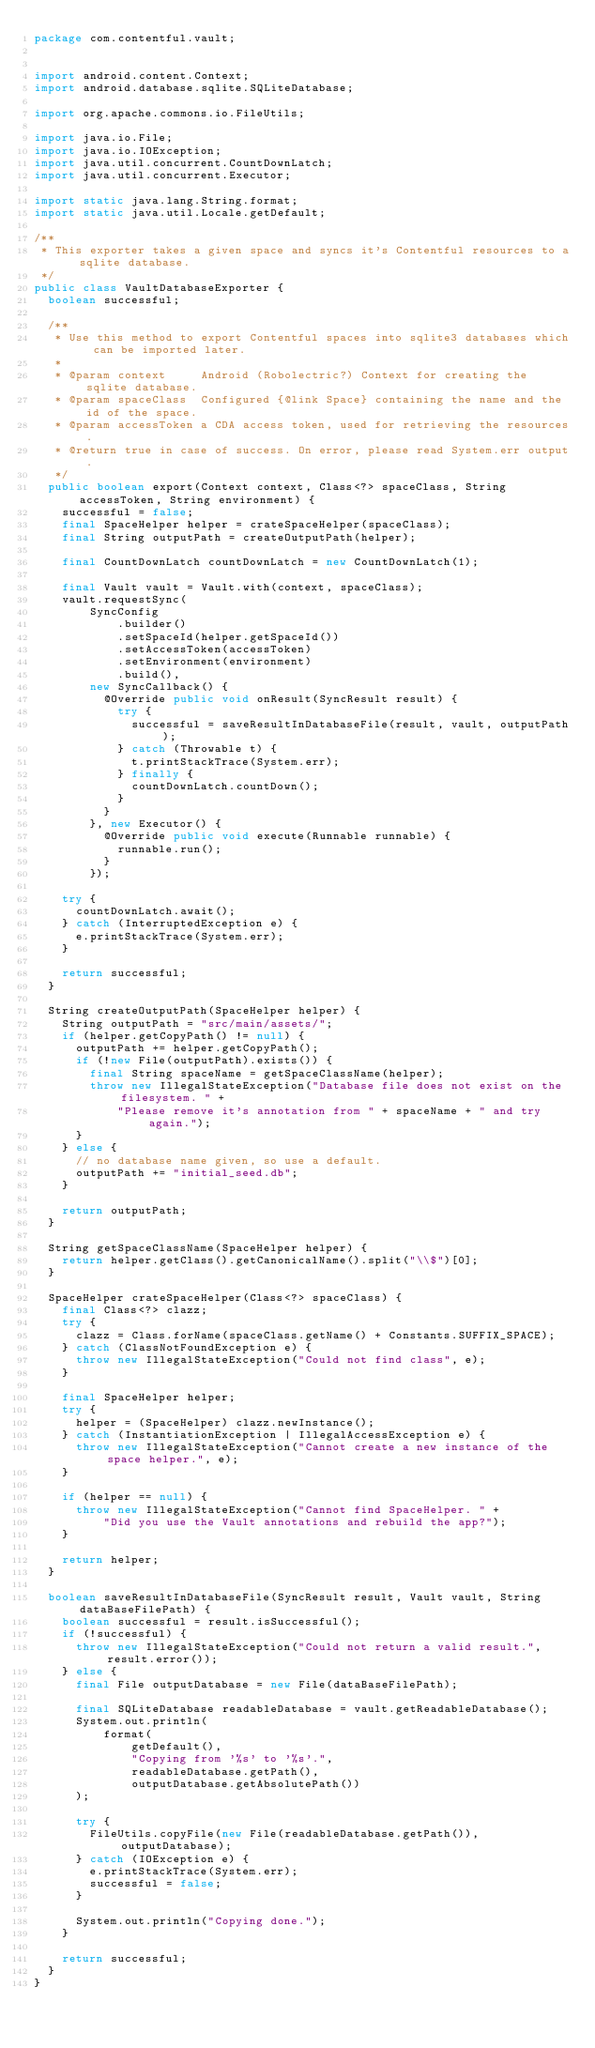Convert code to text. <code><loc_0><loc_0><loc_500><loc_500><_Java_>package com.contentful.vault;


import android.content.Context;
import android.database.sqlite.SQLiteDatabase;

import org.apache.commons.io.FileUtils;

import java.io.File;
import java.io.IOException;
import java.util.concurrent.CountDownLatch;
import java.util.concurrent.Executor;

import static java.lang.String.format;
import static java.util.Locale.getDefault;

/**
 * This exporter takes a given space and syncs it's Contentful resources to a sqlite database.
 */
public class VaultDatabaseExporter {
  boolean successful;

  /**
   * Use this method to export Contentful spaces into sqlite3 databases which can be imported later.
   *
   * @param context     Android (Robolectric?) Context for creating the sqlite database.
   * @param spaceClass  Configured {@link Space} containing the name and the id of the space.
   * @param accessToken a CDA access token, used for retrieving the resources.
   * @return true in case of success. On error, please read System.err output.
   */
  public boolean export(Context context, Class<?> spaceClass, String accessToken, String environment) {
    successful = false;
    final SpaceHelper helper = crateSpaceHelper(spaceClass);
    final String outputPath = createOutputPath(helper);

    final CountDownLatch countDownLatch = new CountDownLatch(1);

    final Vault vault = Vault.with(context, spaceClass);
    vault.requestSync(
        SyncConfig
            .builder()
            .setSpaceId(helper.getSpaceId())
            .setAccessToken(accessToken)
            .setEnvironment(environment)
            .build(),
        new SyncCallback() {
          @Override public void onResult(SyncResult result) {
            try {
              successful = saveResultInDatabaseFile(result, vault, outputPath);
            } catch (Throwable t) {
              t.printStackTrace(System.err);
            } finally {
              countDownLatch.countDown();
            }
          }
        }, new Executor() {
          @Override public void execute(Runnable runnable) {
            runnable.run();
          }
        });

    try {
      countDownLatch.await();
    } catch (InterruptedException e) {
      e.printStackTrace(System.err);
    }

    return successful;
  }

  String createOutputPath(SpaceHelper helper) {
    String outputPath = "src/main/assets/";
    if (helper.getCopyPath() != null) {
      outputPath += helper.getCopyPath();
      if (!new File(outputPath).exists()) {
        final String spaceName = getSpaceClassName(helper);
        throw new IllegalStateException("Database file does not exist on the filesystem. " +
            "Please remove it's annotation from " + spaceName + " and try again.");
      }
    } else {
      // no database name given, so use a default.
      outputPath += "initial_seed.db";
    }

    return outputPath;
  }

  String getSpaceClassName(SpaceHelper helper) {
    return helper.getClass().getCanonicalName().split("\\$")[0];
  }

  SpaceHelper crateSpaceHelper(Class<?> spaceClass) {
    final Class<?> clazz;
    try {
      clazz = Class.forName(spaceClass.getName() + Constants.SUFFIX_SPACE);
    } catch (ClassNotFoundException e) {
      throw new IllegalStateException("Could not find class", e);
    }

    final SpaceHelper helper;
    try {
      helper = (SpaceHelper) clazz.newInstance();
    } catch (InstantiationException | IllegalAccessException e) {
      throw new IllegalStateException("Cannot create a new instance of the space helper.", e);
    }

    if (helper == null) {
      throw new IllegalStateException("Cannot find SpaceHelper. " +
          "Did you use the Vault annotations and rebuild the app?");
    }

    return helper;
  }

  boolean saveResultInDatabaseFile(SyncResult result, Vault vault, String dataBaseFilePath) {
    boolean successful = result.isSuccessful();
    if (!successful) {
      throw new IllegalStateException("Could not return a valid result.", result.error());
    } else {
      final File outputDatabase = new File(dataBaseFilePath);

      final SQLiteDatabase readableDatabase = vault.getReadableDatabase();
      System.out.println(
          format(
              getDefault(),
              "Copying from '%s' to '%s'.",
              readableDatabase.getPath(),
              outputDatabase.getAbsolutePath())
      );

      try {
        FileUtils.copyFile(new File(readableDatabase.getPath()), outputDatabase);
      } catch (IOException e) {
        e.printStackTrace(System.err);
        successful = false;
      }

      System.out.println("Copying done.");
    }

    return successful;
  }
}
</code> 